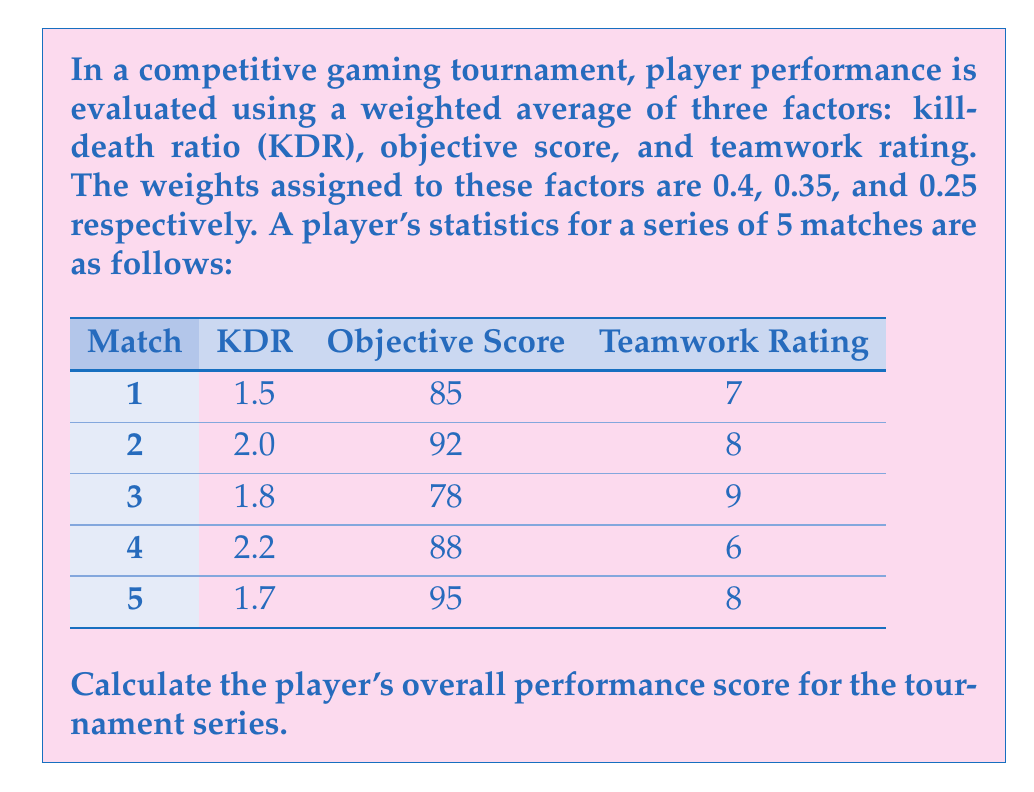Solve this math problem. To calculate the player's overall performance score, we need to follow these steps:

1. Calculate the average for each factor across all 5 matches:

KDR average: 
$$ \frac{1.5 + 2.0 + 1.8 + 2.2 + 1.7}{5} = 1.84 $$

Objective Score average: 
$$ \frac{85 + 92 + 78 + 88 + 95}{5} = 87.6 $$

Teamwork Rating average: 
$$ \frac{7 + 8 + 9 + 6 + 8}{5} = 7.6 $$

2. Apply the weights to each factor:

KDR: $1.84 \times 0.4 = 0.736$
Objective Score: $87.6 \times 0.35 = 30.66$
Teamwork Rating: $7.6 \times 0.25 = 1.9$

3. Sum the weighted scores:

Overall Performance Score = $0.736 + 30.66 + 1.9 = 33.296$

Therefore, the player's overall performance score for the tournament series is 33.296.
Answer: 33.296 